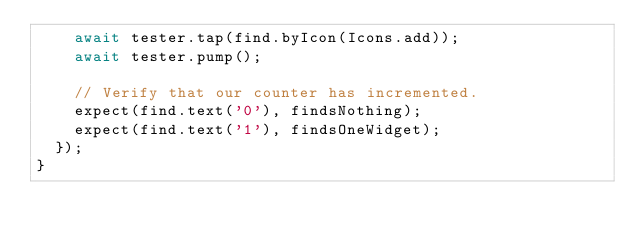Convert code to text. <code><loc_0><loc_0><loc_500><loc_500><_Dart_>    await tester.tap(find.byIcon(Icons.add));
    await tester.pump();

    // Verify that our counter has incremented.
    expect(find.text('0'), findsNothing);
    expect(find.text('1'), findsOneWidget);
  });
}
</code> 